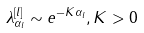Convert formula to latex. <formula><loc_0><loc_0><loc_500><loc_500>\lambda _ { \alpha _ { l } } ^ { [ l ] } \sim e ^ { - K \alpha _ { l } } , K > 0</formula> 